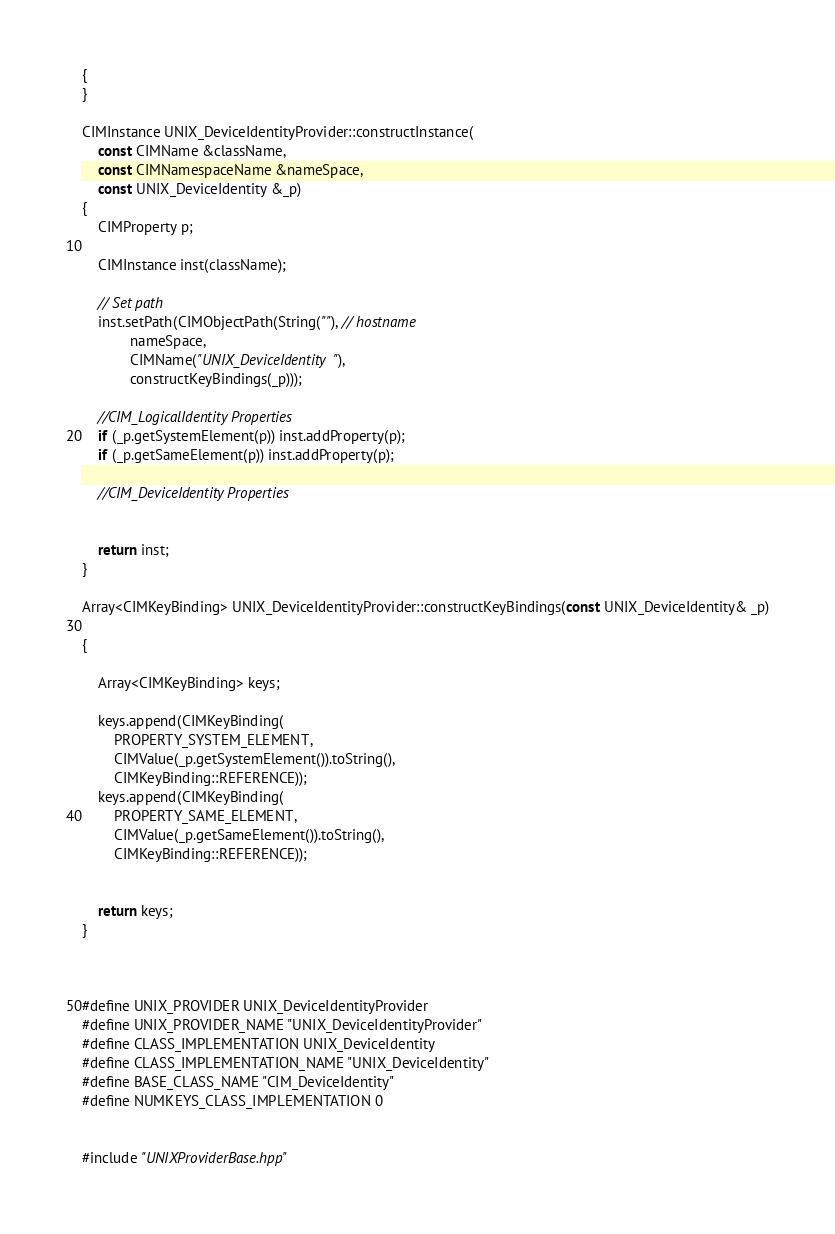<code> <loc_0><loc_0><loc_500><loc_500><_C++_>{
}

CIMInstance UNIX_DeviceIdentityProvider::constructInstance(
	const CIMName &className,
	const CIMNamespaceName &nameSpace,
	const UNIX_DeviceIdentity &_p)
{
	CIMProperty p;

	CIMInstance inst(className);

	// Set path
	inst.setPath(CIMObjectPath(String(""), // hostname
			nameSpace,
			CIMName("UNIX_DeviceIdentity"),
			constructKeyBindings(_p)));

	//CIM_LogicalIdentity Properties
	if (_p.getSystemElement(p)) inst.addProperty(p);
	if (_p.getSameElement(p)) inst.addProperty(p);

	//CIM_DeviceIdentity Properties


	return inst;
}

Array<CIMKeyBinding> UNIX_DeviceIdentityProvider::constructKeyBindings(const UNIX_DeviceIdentity& _p)

{

	Array<CIMKeyBinding> keys;

	keys.append(CIMKeyBinding(
		PROPERTY_SYSTEM_ELEMENT,
		CIMValue(_p.getSystemElement()).toString(),
		CIMKeyBinding::REFERENCE));
	keys.append(CIMKeyBinding(
		PROPERTY_SAME_ELEMENT,
		CIMValue(_p.getSameElement()).toString(),
		CIMKeyBinding::REFERENCE));


	return keys;
}



#define UNIX_PROVIDER UNIX_DeviceIdentityProvider
#define UNIX_PROVIDER_NAME "UNIX_DeviceIdentityProvider"
#define CLASS_IMPLEMENTATION UNIX_DeviceIdentity
#define CLASS_IMPLEMENTATION_NAME "UNIX_DeviceIdentity"
#define BASE_CLASS_NAME "CIM_DeviceIdentity"
#define NUMKEYS_CLASS_IMPLEMENTATION 0


#include "UNIXProviderBase.hpp"

</code> 